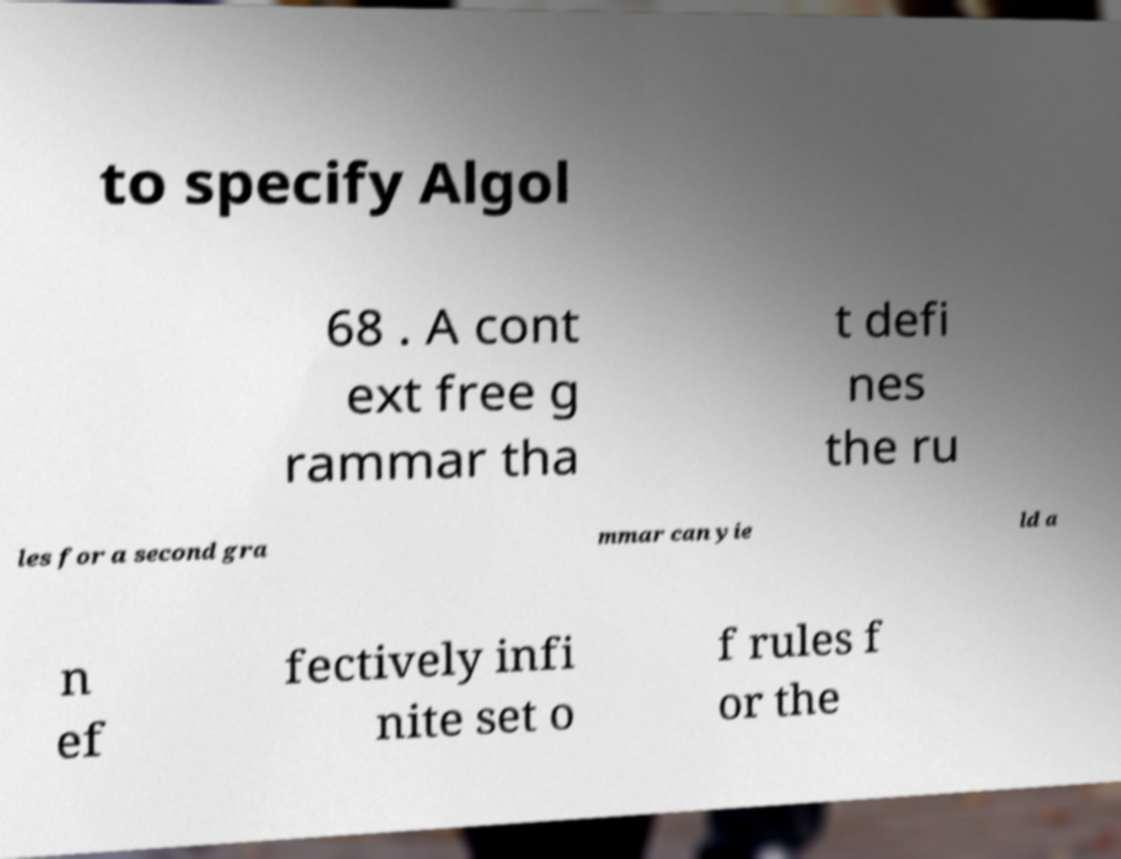Please read and relay the text visible in this image. What does it say? to specify Algol 68 . A cont ext free g rammar tha t defi nes the ru les for a second gra mmar can yie ld a n ef fectively infi nite set o f rules f or the 